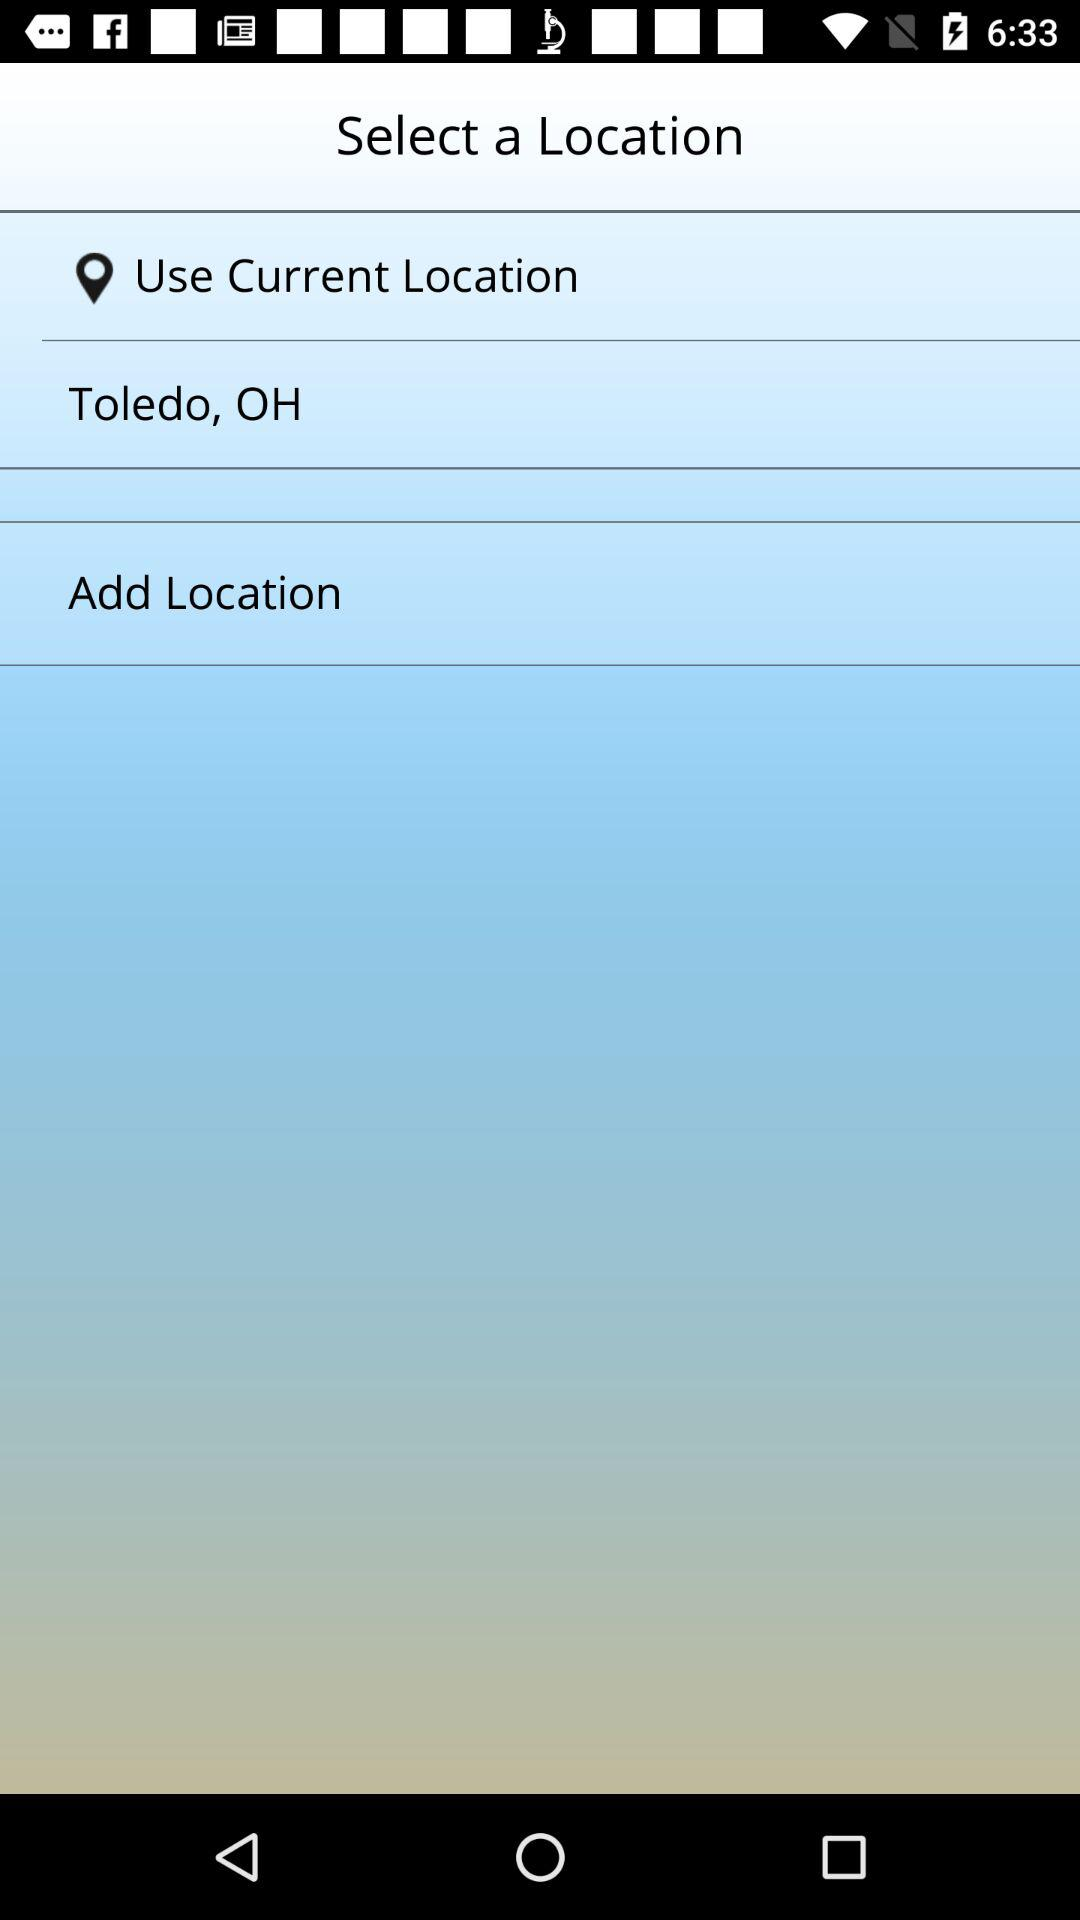What is the name of the application?
When the provided information is insufficient, respond with <no answer>. <no answer> 